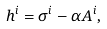<formula> <loc_0><loc_0><loc_500><loc_500>h ^ { i } = \sigma ^ { i } - \alpha A ^ { i } ,</formula> 